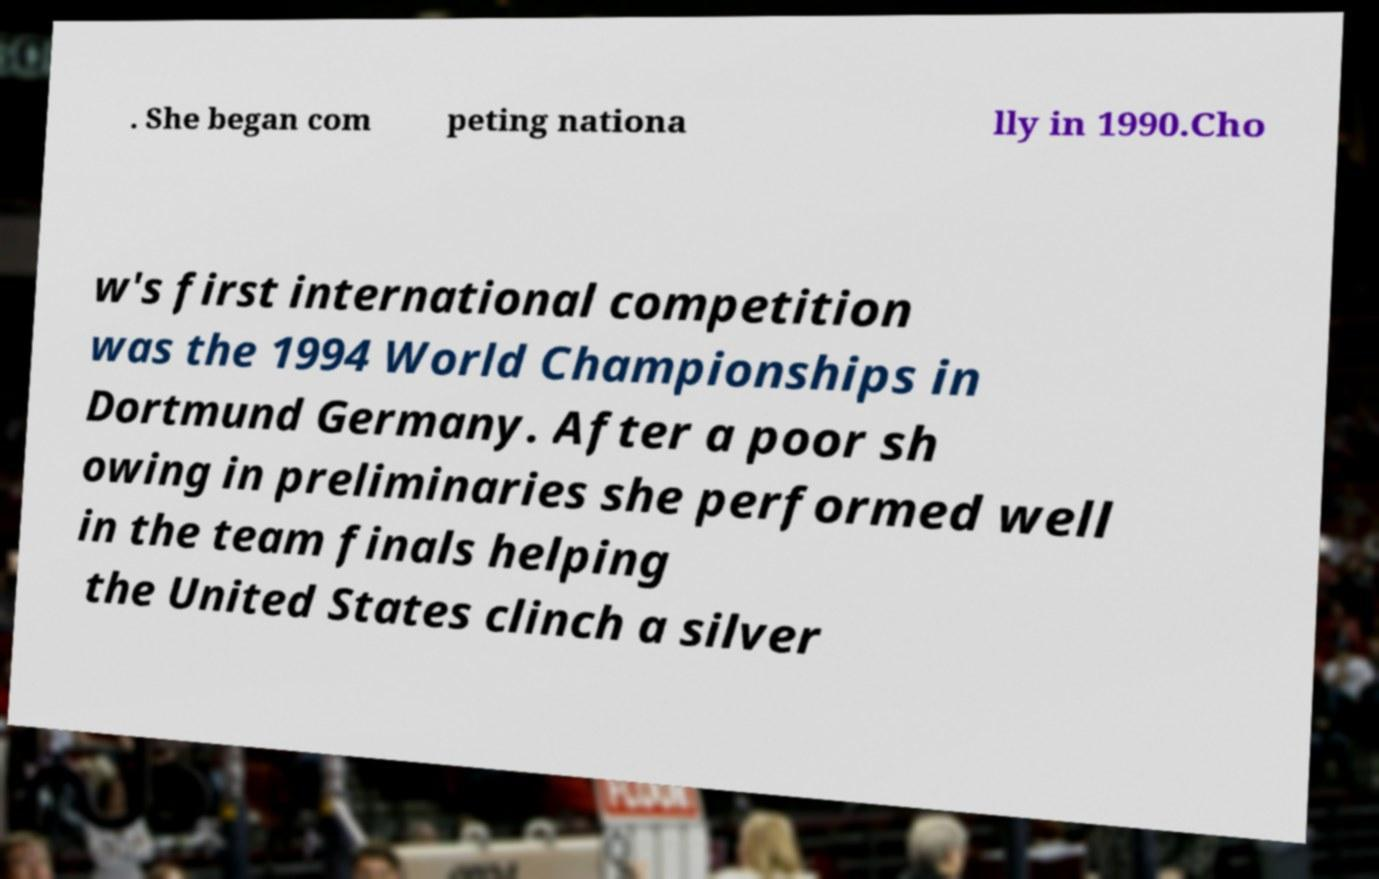For documentation purposes, I need the text within this image transcribed. Could you provide that? . She began com peting nationa lly in 1990.Cho w's first international competition was the 1994 World Championships in Dortmund Germany. After a poor sh owing in preliminaries she performed well in the team finals helping the United States clinch a silver 